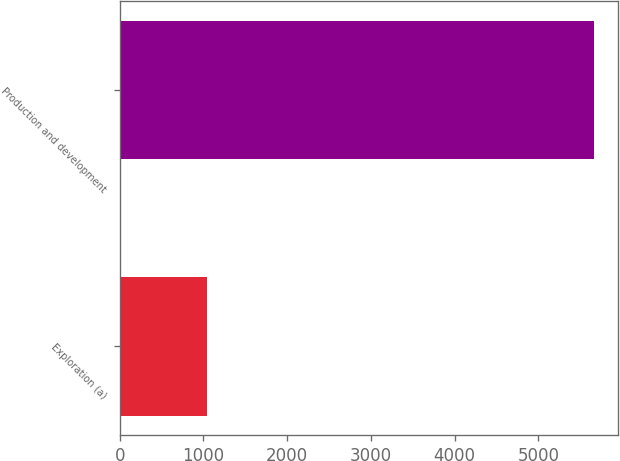Convert chart to OTSL. <chart><loc_0><loc_0><loc_500><loc_500><bar_chart><fcel>Exploration (a)<fcel>Production and development<nl><fcel>1044<fcel>5666<nl></chart> 